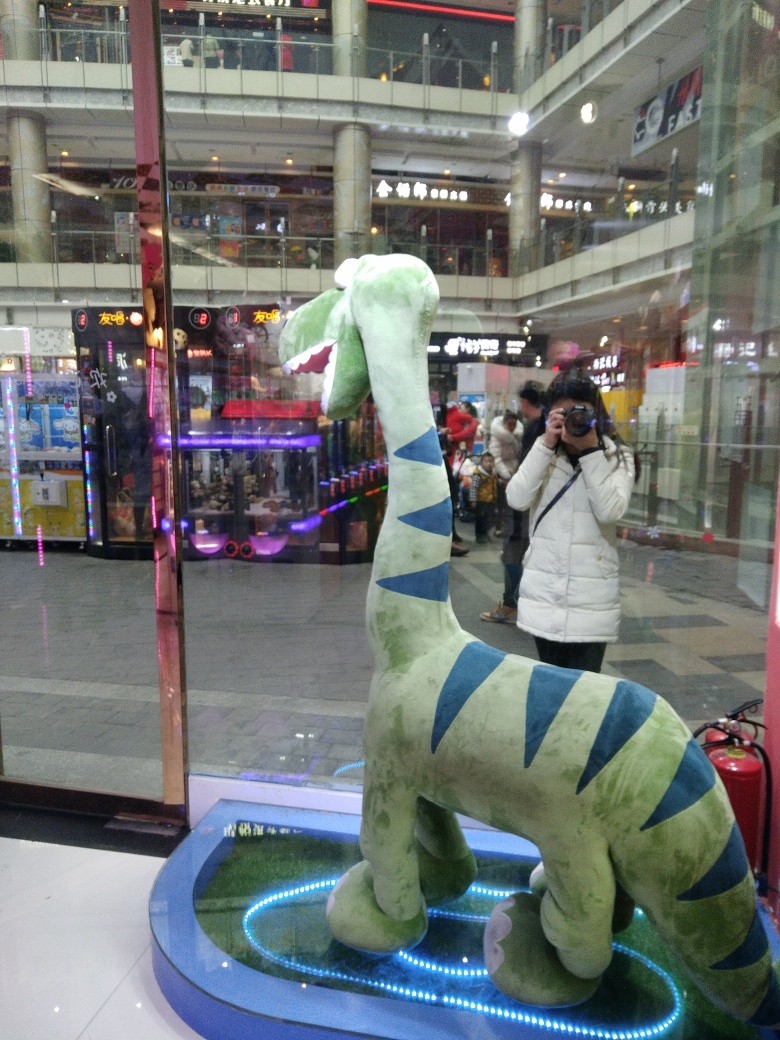What type of location is this figure displayed in, and how does the setting affect the presentation? The figure appears to be displayed in a brightly lit, multi-level shopping arcade. The bustling ambience and commercial setting may lead to frequent distractions, detracting from the figure's visibility and the viewer's ability to focus purely on its details. Could you describe the general appearance and posture of the figure in the showcase? Certainly! The figure is a plush toy resembling a stylized dinosaur or dragon with a playful design, characterized by its light green color with blue stripes. It sports an upright stance with a slightly curved neck and a tail that curls inward, exuding both friendliness and whimsy. 